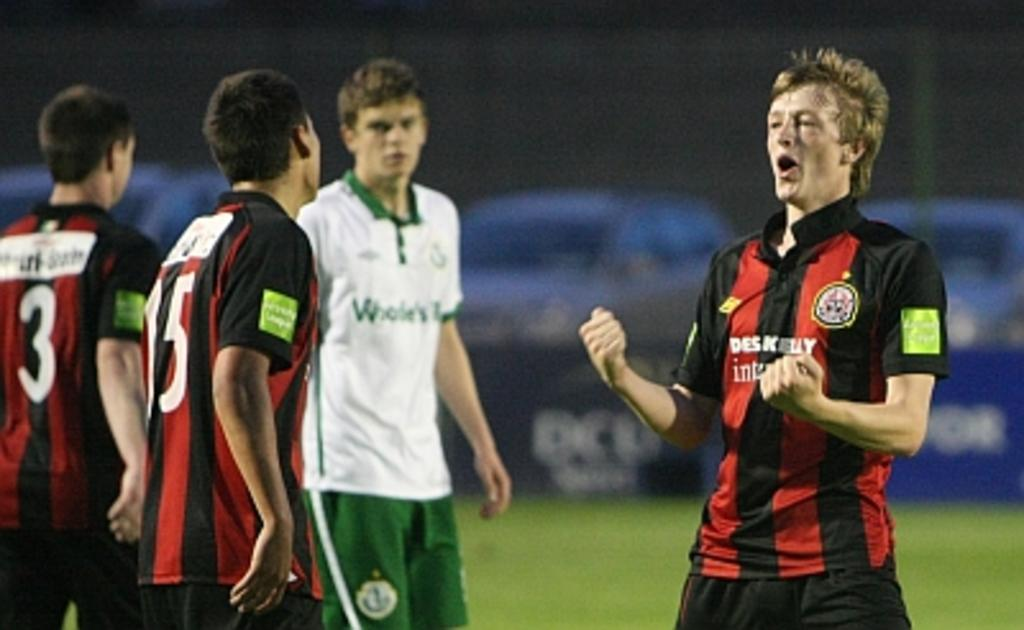<image>
Provide a brief description of the given image. Player number 15 look at his teammate who is yelling. 